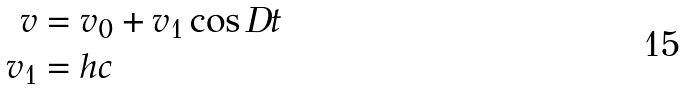Convert formula to latex. <formula><loc_0><loc_0><loc_500><loc_500>v & = v _ { 0 } + v _ { 1 } \cos D t \\ v _ { 1 } & = h c</formula> 